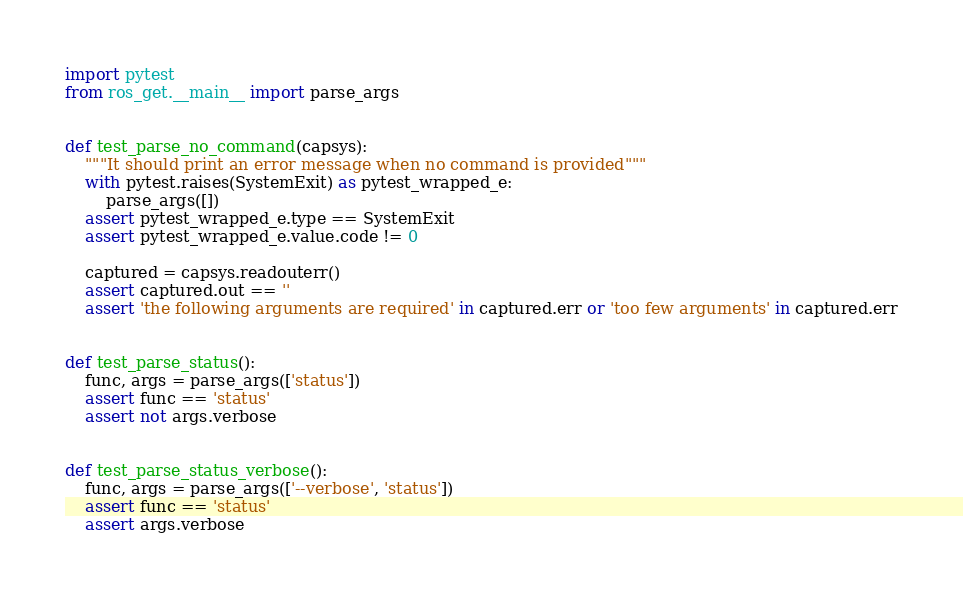<code> <loc_0><loc_0><loc_500><loc_500><_Python_>import pytest
from ros_get.__main__ import parse_args


def test_parse_no_command(capsys):
    """It should print an error message when no command is provided"""
    with pytest.raises(SystemExit) as pytest_wrapped_e:
        parse_args([])
    assert pytest_wrapped_e.type == SystemExit
    assert pytest_wrapped_e.value.code != 0

    captured = capsys.readouterr()
    assert captured.out == ''
    assert 'the following arguments are required' in captured.err or 'too few arguments' in captured.err


def test_parse_status():
    func, args = parse_args(['status'])
    assert func == 'status'
    assert not args.verbose


def test_parse_status_verbose():
    func, args = parse_args(['--verbose', 'status'])
    assert func == 'status'
    assert args.verbose
</code> 